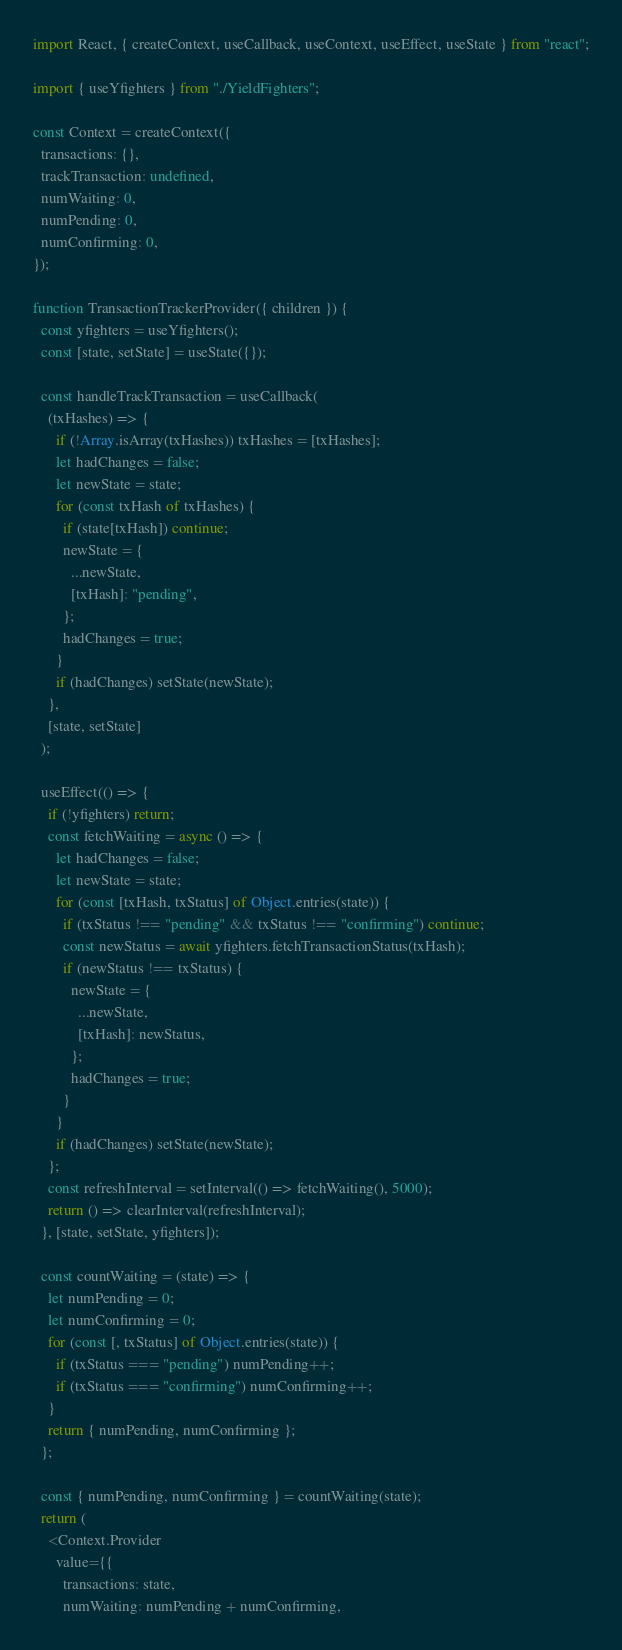Convert code to text. <code><loc_0><loc_0><loc_500><loc_500><_JavaScript_>import React, { createContext, useCallback, useContext, useEffect, useState } from "react";

import { useYfighters } from "./YieldFighters";

const Context = createContext({
  transactions: {},
  trackTransaction: undefined,
  numWaiting: 0,
  numPending: 0,
  numConfirming: 0,
});

function TransactionTrackerProvider({ children }) {
  const yfighters = useYfighters();
  const [state, setState] = useState({});

  const handleTrackTransaction = useCallback(
    (txHashes) => {
      if (!Array.isArray(txHashes)) txHashes = [txHashes];
      let hadChanges = false;
      let newState = state;
      for (const txHash of txHashes) {
        if (state[txHash]) continue;
        newState = {
          ...newState,
          [txHash]: "pending",
        };
        hadChanges = true;
      }
      if (hadChanges) setState(newState);
    },
    [state, setState]
  );

  useEffect(() => {
    if (!yfighters) return;
    const fetchWaiting = async () => {
      let hadChanges = false;
      let newState = state;
      for (const [txHash, txStatus] of Object.entries(state)) {
        if (txStatus !== "pending" && txStatus !== "confirming") continue;
        const newStatus = await yfighters.fetchTransactionStatus(txHash);
        if (newStatus !== txStatus) {
          newState = {
            ...newState,
            [txHash]: newStatus,
          };
          hadChanges = true;
        }
      }
      if (hadChanges) setState(newState);
    };
    const refreshInterval = setInterval(() => fetchWaiting(), 5000);
    return () => clearInterval(refreshInterval);
  }, [state, setState, yfighters]);

  const countWaiting = (state) => {
    let numPending = 0;
    let numConfirming = 0;
    for (const [, txStatus] of Object.entries(state)) {
      if (txStatus === "pending") numPending++;
      if (txStatus === "confirming") numConfirming++;
    }
    return { numPending, numConfirming };
  };

  const { numPending, numConfirming } = countWaiting(state);
  return (
    <Context.Provider
      value={{
        transactions: state,
        numWaiting: numPending + numConfirming,</code> 